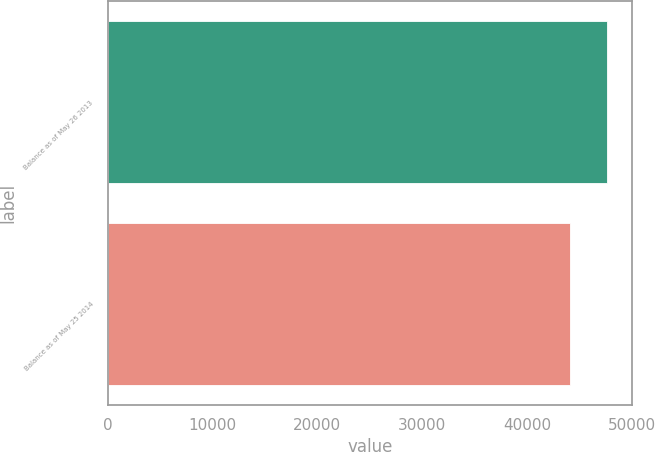<chart> <loc_0><loc_0><loc_500><loc_500><bar_chart><fcel>Balance as of May 26 2013<fcel>Balance as of May 25 2014<nl><fcel>47672.1<fcel>44169<nl></chart> 